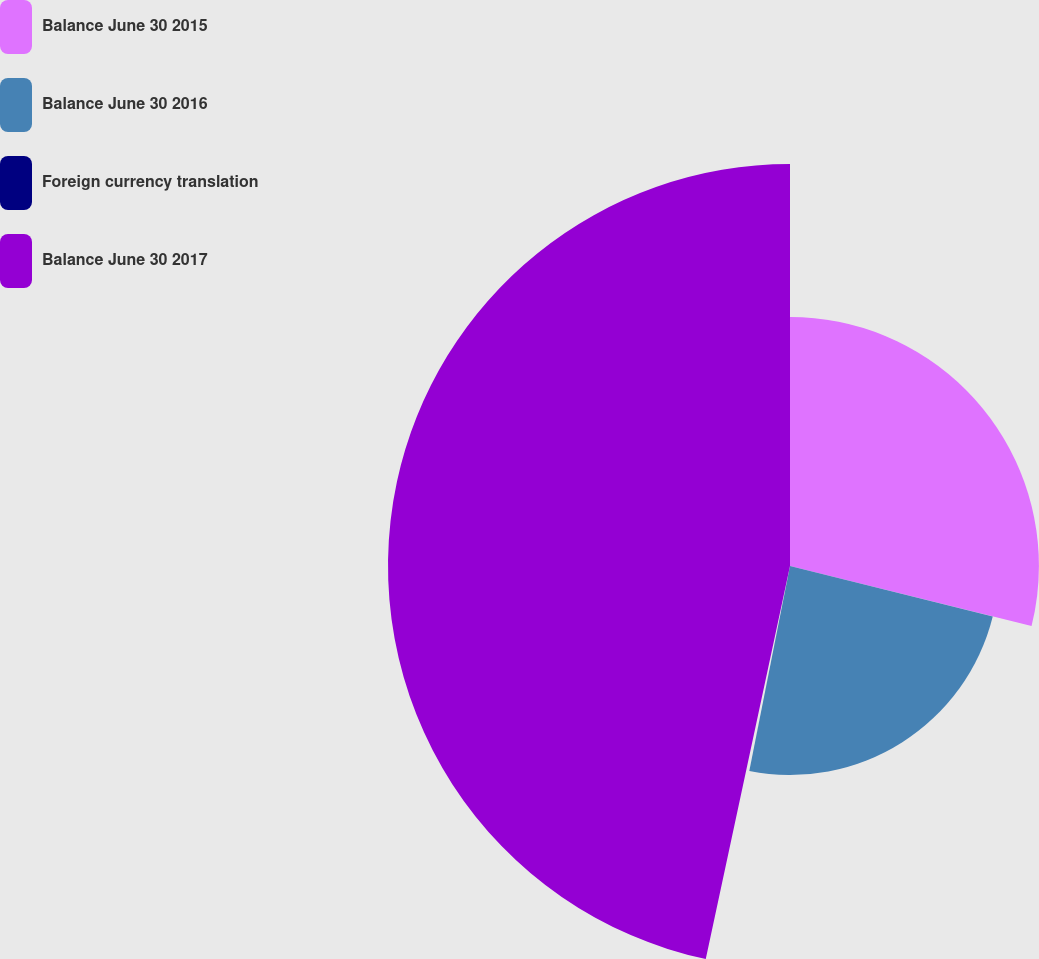<chart> <loc_0><loc_0><loc_500><loc_500><pie_chart><fcel>Balance June 30 2015<fcel>Balance June 30 2016<fcel>Foreign currency translation<fcel>Balance June 30 2017<nl><fcel>28.88%<fcel>24.24%<fcel>0.24%<fcel>46.64%<nl></chart> 